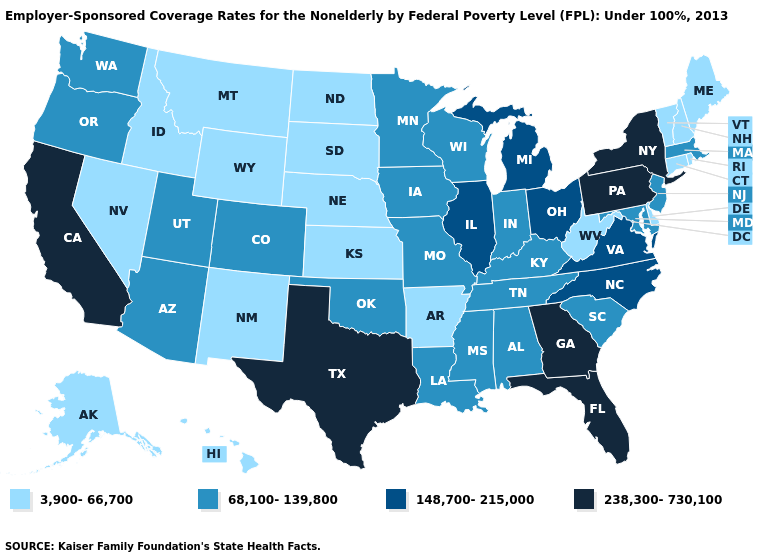What is the value of Hawaii?
Short answer required. 3,900-66,700. Name the states that have a value in the range 148,700-215,000?
Keep it brief. Illinois, Michigan, North Carolina, Ohio, Virginia. Does North Carolina have the lowest value in the USA?
Give a very brief answer. No. Which states have the highest value in the USA?
Quick response, please. California, Florida, Georgia, New York, Pennsylvania, Texas. What is the value of Utah?
Give a very brief answer. 68,100-139,800. Name the states that have a value in the range 68,100-139,800?
Concise answer only. Alabama, Arizona, Colorado, Indiana, Iowa, Kentucky, Louisiana, Maryland, Massachusetts, Minnesota, Mississippi, Missouri, New Jersey, Oklahoma, Oregon, South Carolina, Tennessee, Utah, Washington, Wisconsin. Which states have the lowest value in the South?
Quick response, please. Arkansas, Delaware, West Virginia. How many symbols are there in the legend?
Write a very short answer. 4. What is the value of Pennsylvania?
Give a very brief answer. 238,300-730,100. Does Wyoming have the lowest value in the West?
Concise answer only. Yes. Name the states that have a value in the range 148,700-215,000?
Give a very brief answer. Illinois, Michigan, North Carolina, Ohio, Virginia. Name the states that have a value in the range 68,100-139,800?
Answer briefly. Alabama, Arizona, Colorado, Indiana, Iowa, Kentucky, Louisiana, Maryland, Massachusetts, Minnesota, Mississippi, Missouri, New Jersey, Oklahoma, Oregon, South Carolina, Tennessee, Utah, Washington, Wisconsin. What is the value of Ohio?
Answer briefly. 148,700-215,000. Name the states that have a value in the range 148,700-215,000?
Answer briefly. Illinois, Michigan, North Carolina, Ohio, Virginia. Name the states that have a value in the range 68,100-139,800?
Write a very short answer. Alabama, Arizona, Colorado, Indiana, Iowa, Kentucky, Louisiana, Maryland, Massachusetts, Minnesota, Mississippi, Missouri, New Jersey, Oklahoma, Oregon, South Carolina, Tennessee, Utah, Washington, Wisconsin. 